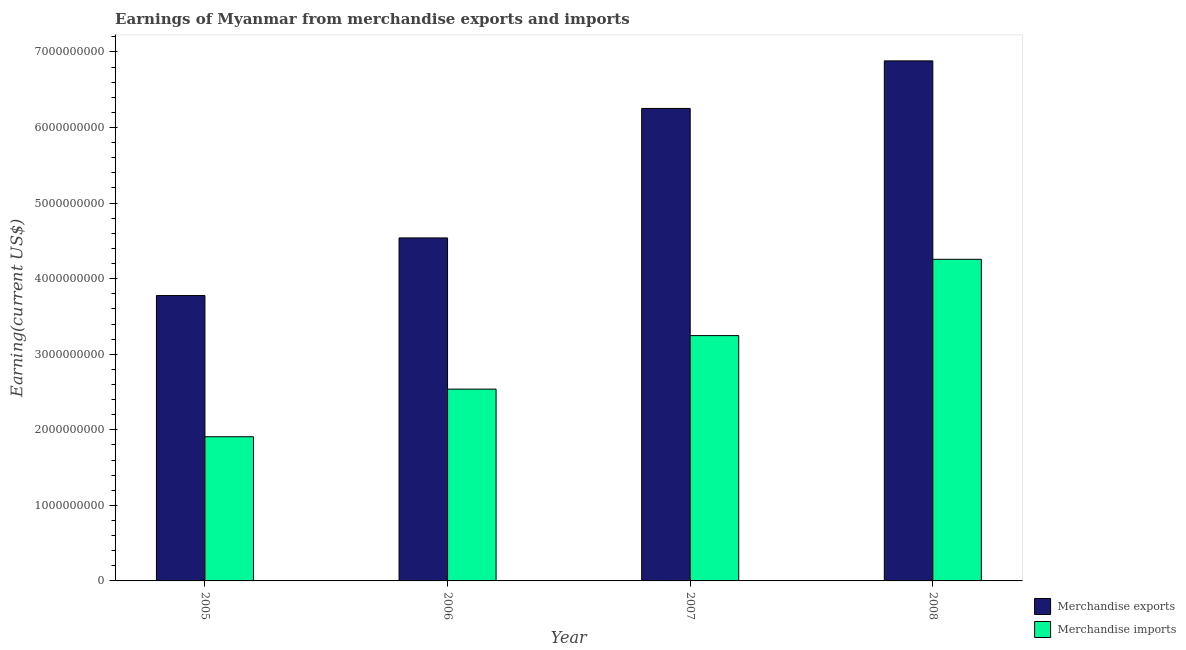How many different coloured bars are there?
Keep it short and to the point. 2. Are the number of bars per tick equal to the number of legend labels?
Your response must be concise. Yes. How many bars are there on the 2nd tick from the left?
Your answer should be very brief. 2. How many bars are there on the 4th tick from the right?
Offer a terse response. 2. What is the earnings from merchandise imports in 2006?
Your response must be concise. 2.54e+09. Across all years, what is the maximum earnings from merchandise imports?
Ensure brevity in your answer.  4.26e+09. Across all years, what is the minimum earnings from merchandise exports?
Ensure brevity in your answer.  3.78e+09. In which year was the earnings from merchandise exports minimum?
Ensure brevity in your answer.  2005. What is the total earnings from merchandise imports in the graph?
Give a very brief answer. 1.19e+1. What is the difference between the earnings from merchandise exports in 2005 and that in 2008?
Give a very brief answer. -3.11e+09. What is the difference between the earnings from merchandise exports in 2006 and the earnings from merchandise imports in 2007?
Ensure brevity in your answer.  -1.71e+09. What is the average earnings from merchandise imports per year?
Offer a terse response. 2.99e+09. In the year 2007, what is the difference between the earnings from merchandise imports and earnings from merchandise exports?
Ensure brevity in your answer.  0. What is the ratio of the earnings from merchandise imports in 2005 to that in 2007?
Give a very brief answer. 0.59. Is the earnings from merchandise exports in 2006 less than that in 2008?
Provide a short and direct response. Yes. Is the difference between the earnings from merchandise exports in 2005 and 2006 greater than the difference between the earnings from merchandise imports in 2005 and 2006?
Provide a succinct answer. No. What is the difference between the highest and the second highest earnings from merchandise exports?
Provide a succinct answer. 6.30e+08. What is the difference between the highest and the lowest earnings from merchandise imports?
Offer a very short reply. 2.35e+09. Is the sum of the earnings from merchandise imports in 2005 and 2007 greater than the maximum earnings from merchandise exports across all years?
Ensure brevity in your answer.  Yes. What does the 2nd bar from the left in 2008 represents?
Your answer should be very brief. Merchandise imports. What does the 2nd bar from the right in 2008 represents?
Your response must be concise. Merchandise exports. Are all the bars in the graph horizontal?
Offer a very short reply. No. How many years are there in the graph?
Give a very brief answer. 4. What is the difference between two consecutive major ticks on the Y-axis?
Your answer should be compact. 1.00e+09. Does the graph contain any zero values?
Your response must be concise. No. How many legend labels are there?
Ensure brevity in your answer.  2. What is the title of the graph?
Ensure brevity in your answer.  Earnings of Myanmar from merchandise exports and imports. What is the label or title of the X-axis?
Your answer should be very brief. Year. What is the label or title of the Y-axis?
Your answer should be very brief. Earning(current US$). What is the Earning(current US$) in Merchandise exports in 2005?
Give a very brief answer. 3.78e+09. What is the Earning(current US$) in Merchandise imports in 2005?
Offer a terse response. 1.91e+09. What is the Earning(current US$) in Merchandise exports in 2006?
Your response must be concise. 4.54e+09. What is the Earning(current US$) in Merchandise imports in 2006?
Offer a terse response. 2.54e+09. What is the Earning(current US$) of Merchandise exports in 2007?
Your response must be concise. 6.25e+09. What is the Earning(current US$) of Merchandise imports in 2007?
Offer a terse response. 3.25e+09. What is the Earning(current US$) in Merchandise exports in 2008?
Make the answer very short. 6.88e+09. What is the Earning(current US$) in Merchandise imports in 2008?
Keep it short and to the point. 4.26e+09. Across all years, what is the maximum Earning(current US$) in Merchandise exports?
Your answer should be compact. 6.88e+09. Across all years, what is the maximum Earning(current US$) of Merchandise imports?
Make the answer very short. 4.26e+09. Across all years, what is the minimum Earning(current US$) of Merchandise exports?
Keep it short and to the point. 3.78e+09. Across all years, what is the minimum Earning(current US$) of Merchandise imports?
Give a very brief answer. 1.91e+09. What is the total Earning(current US$) in Merchandise exports in the graph?
Your answer should be compact. 2.15e+1. What is the total Earning(current US$) in Merchandise imports in the graph?
Provide a short and direct response. 1.19e+1. What is the difference between the Earning(current US$) of Merchandise exports in 2005 and that in 2006?
Give a very brief answer. -7.63e+08. What is the difference between the Earning(current US$) in Merchandise imports in 2005 and that in 2006?
Ensure brevity in your answer.  -6.30e+08. What is the difference between the Earning(current US$) in Merchandise exports in 2005 and that in 2007?
Your answer should be compact. -2.48e+09. What is the difference between the Earning(current US$) in Merchandise imports in 2005 and that in 2007?
Offer a very short reply. -1.34e+09. What is the difference between the Earning(current US$) of Merchandise exports in 2005 and that in 2008?
Provide a short and direct response. -3.11e+09. What is the difference between the Earning(current US$) in Merchandise imports in 2005 and that in 2008?
Ensure brevity in your answer.  -2.35e+09. What is the difference between the Earning(current US$) in Merchandise exports in 2006 and that in 2007?
Your answer should be very brief. -1.71e+09. What is the difference between the Earning(current US$) of Merchandise imports in 2006 and that in 2007?
Offer a very short reply. -7.08e+08. What is the difference between the Earning(current US$) of Merchandise exports in 2006 and that in 2008?
Give a very brief answer. -2.34e+09. What is the difference between the Earning(current US$) in Merchandise imports in 2006 and that in 2008?
Your answer should be very brief. -1.72e+09. What is the difference between the Earning(current US$) of Merchandise exports in 2007 and that in 2008?
Offer a terse response. -6.30e+08. What is the difference between the Earning(current US$) of Merchandise imports in 2007 and that in 2008?
Provide a succinct answer. -1.01e+09. What is the difference between the Earning(current US$) in Merchandise exports in 2005 and the Earning(current US$) in Merchandise imports in 2006?
Provide a succinct answer. 1.24e+09. What is the difference between the Earning(current US$) of Merchandise exports in 2005 and the Earning(current US$) of Merchandise imports in 2007?
Your response must be concise. 5.30e+08. What is the difference between the Earning(current US$) in Merchandise exports in 2005 and the Earning(current US$) in Merchandise imports in 2008?
Provide a succinct answer. -4.80e+08. What is the difference between the Earning(current US$) in Merchandise exports in 2006 and the Earning(current US$) in Merchandise imports in 2007?
Offer a very short reply. 1.29e+09. What is the difference between the Earning(current US$) in Merchandise exports in 2006 and the Earning(current US$) in Merchandise imports in 2008?
Your answer should be compact. 2.83e+08. What is the difference between the Earning(current US$) of Merchandise exports in 2007 and the Earning(current US$) of Merchandise imports in 2008?
Your response must be concise. 2.00e+09. What is the average Earning(current US$) of Merchandise exports per year?
Provide a succinct answer. 5.36e+09. What is the average Earning(current US$) of Merchandise imports per year?
Your response must be concise. 2.99e+09. In the year 2005, what is the difference between the Earning(current US$) in Merchandise exports and Earning(current US$) in Merchandise imports?
Your answer should be very brief. 1.87e+09. In the year 2006, what is the difference between the Earning(current US$) in Merchandise exports and Earning(current US$) in Merchandise imports?
Your answer should be very brief. 2.00e+09. In the year 2007, what is the difference between the Earning(current US$) in Merchandise exports and Earning(current US$) in Merchandise imports?
Ensure brevity in your answer.  3.01e+09. In the year 2008, what is the difference between the Earning(current US$) in Merchandise exports and Earning(current US$) in Merchandise imports?
Ensure brevity in your answer.  2.63e+09. What is the ratio of the Earning(current US$) of Merchandise exports in 2005 to that in 2006?
Your answer should be compact. 0.83. What is the ratio of the Earning(current US$) in Merchandise imports in 2005 to that in 2006?
Offer a very short reply. 0.75. What is the ratio of the Earning(current US$) in Merchandise exports in 2005 to that in 2007?
Make the answer very short. 0.6. What is the ratio of the Earning(current US$) in Merchandise imports in 2005 to that in 2007?
Your response must be concise. 0.59. What is the ratio of the Earning(current US$) in Merchandise exports in 2005 to that in 2008?
Give a very brief answer. 0.55. What is the ratio of the Earning(current US$) in Merchandise imports in 2005 to that in 2008?
Your answer should be compact. 0.45. What is the ratio of the Earning(current US$) of Merchandise exports in 2006 to that in 2007?
Offer a very short reply. 0.73. What is the ratio of the Earning(current US$) of Merchandise imports in 2006 to that in 2007?
Your answer should be very brief. 0.78. What is the ratio of the Earning(current US$) in Merchandise exports in 2006 to that in 2008?
Keep it short and to the point. 0.66. What is the ratio of the Earning(current US$) in Merchandise imports in 2006 to that in 2008?
Give a very brief answer. 0.6. What is the ratio of the Earning(current US$) of Merchandise exports in 2007 to that in 2008?
Provide a short and direct response. 0.91. What is the ratio of the Earning(current US$) in Merchandise imports in 2007 to that in 2008?
Ensure brevity in your answer.  0.76. What is the difference between the highest and the second highest Earning(current US$) of Merchandise exports?
Your response must be concise. 6.30e+08. What is the difference between the highest and the second highest Earning(current US$) of Merchandise imports?
Your answer should be very brief. 1.01e+09. What is the difference between the highest and the lowest Earning(current US$) of Merchandise exports?
Your response must be concise. 3.11e+09. What is the difference between the highest and the lowest Earning(current US$) in Merchandise imports?
Ensure brevity in your answer.  2.35e+09. 